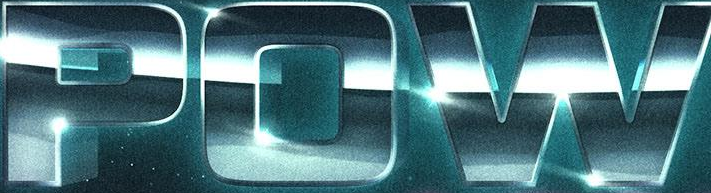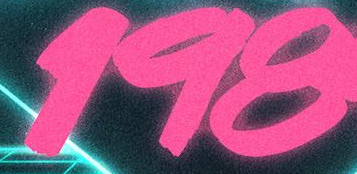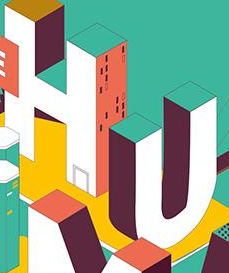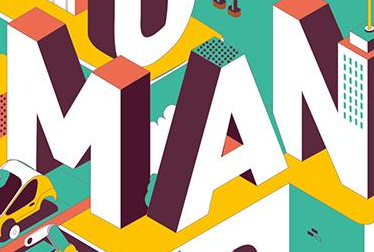What words are shown in these images in order, separated by a semicolon? POW; 198; HU; MAN 